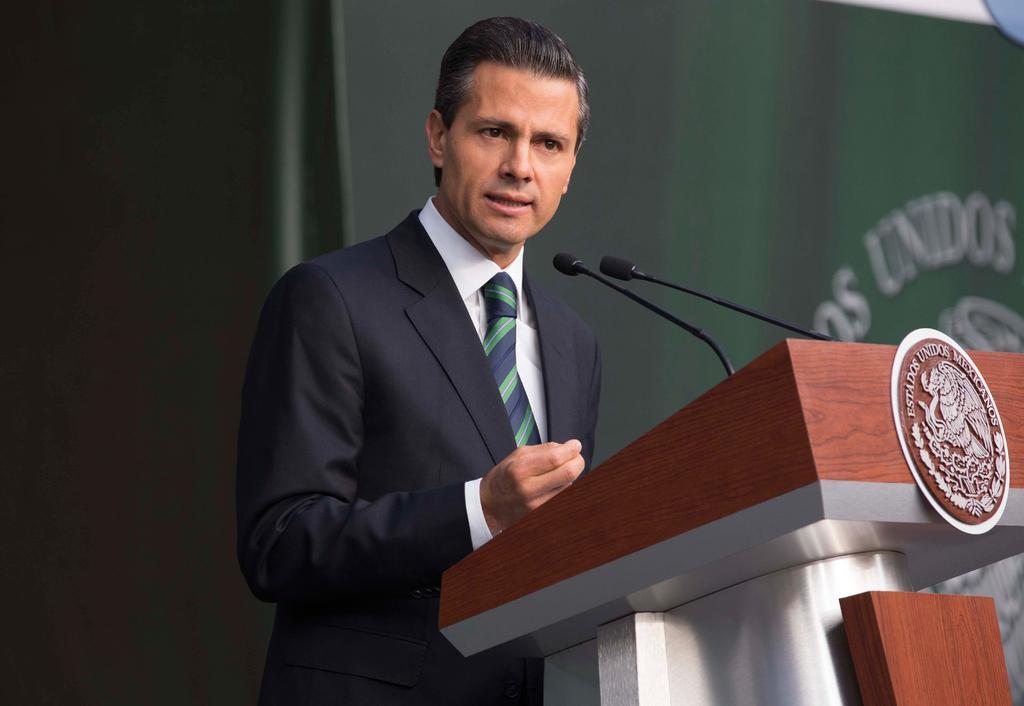Can you describe this image briefly? The picture consists of a person in black suit talking, in front of him there is a podium. On the podium there are two mics. The background is blurred. 